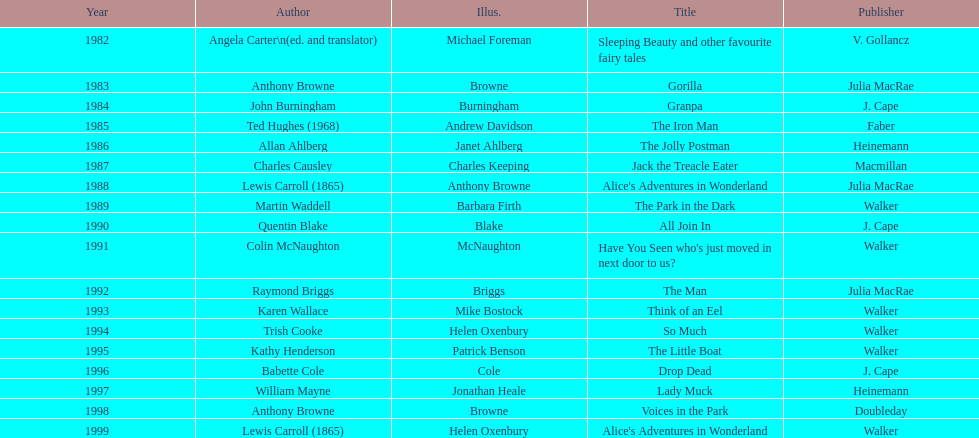How many total titles were published by walker? 5. 